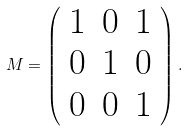Convert formula to latex. <formula><loc_0><loc_0><loc_500><loc_500>M = \left ( \begin{array} { c c c } 1 & 0 & 1 \\ 0 & 1 & 0 \\ 0 & 0 & 1 \end{array} \right ) .</formula> 